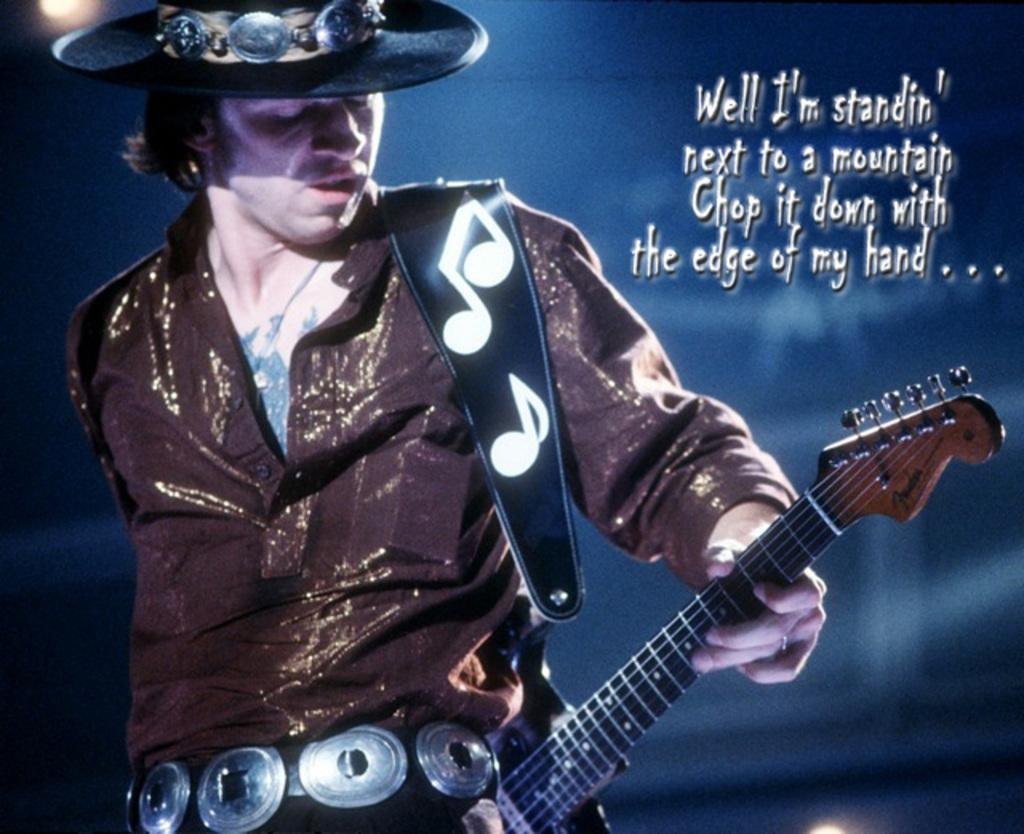What is the main subject of the image? The main subject of the image is a man. What is the man doing in the image? The man is standing and playing a guitar. What type of wrench is the man using to tune the guitar in the image? There is no wrench present in the image, and the man is not tuning the guitar. What kind of wine is the man holding while playing the guitar in the image? There is no wine present in the image, and the man is not holding anything while playing the guitar. 